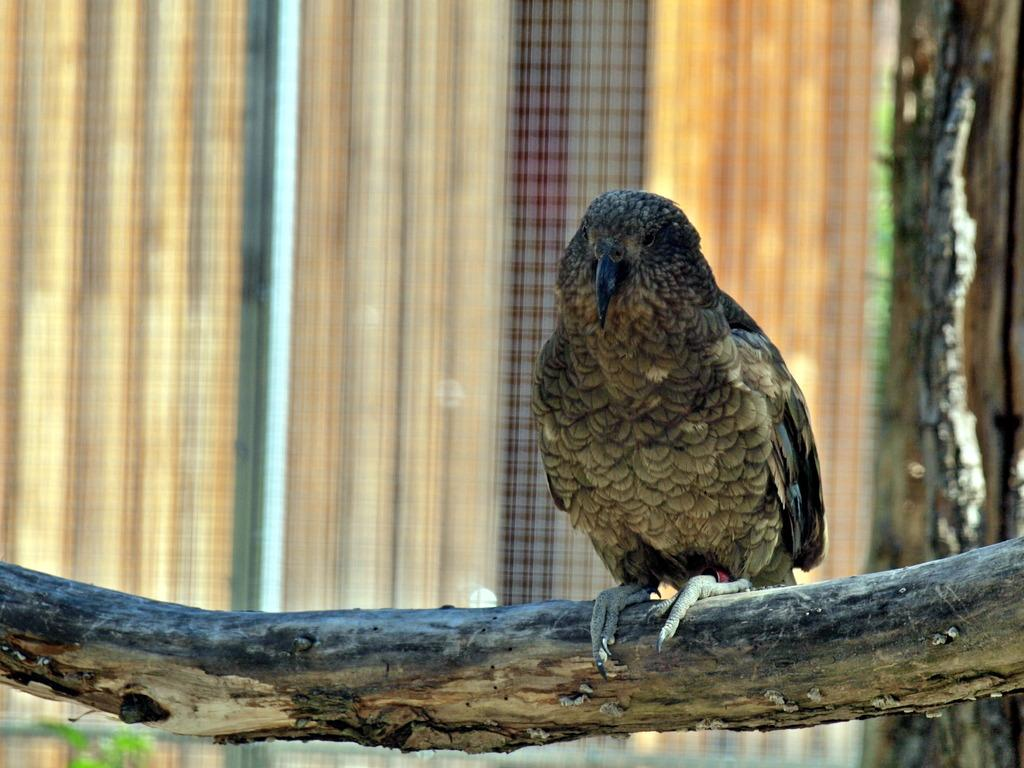What type of bird is in the picture? There is a Cooper's hawk in the picture. What is the hawk standing on? The hawk is standing on a wooden stick. Can you describe the background of the image? There are other objects in the background of the image. What type of glass is the hawk holding in the image? There is no glass present in the image. 